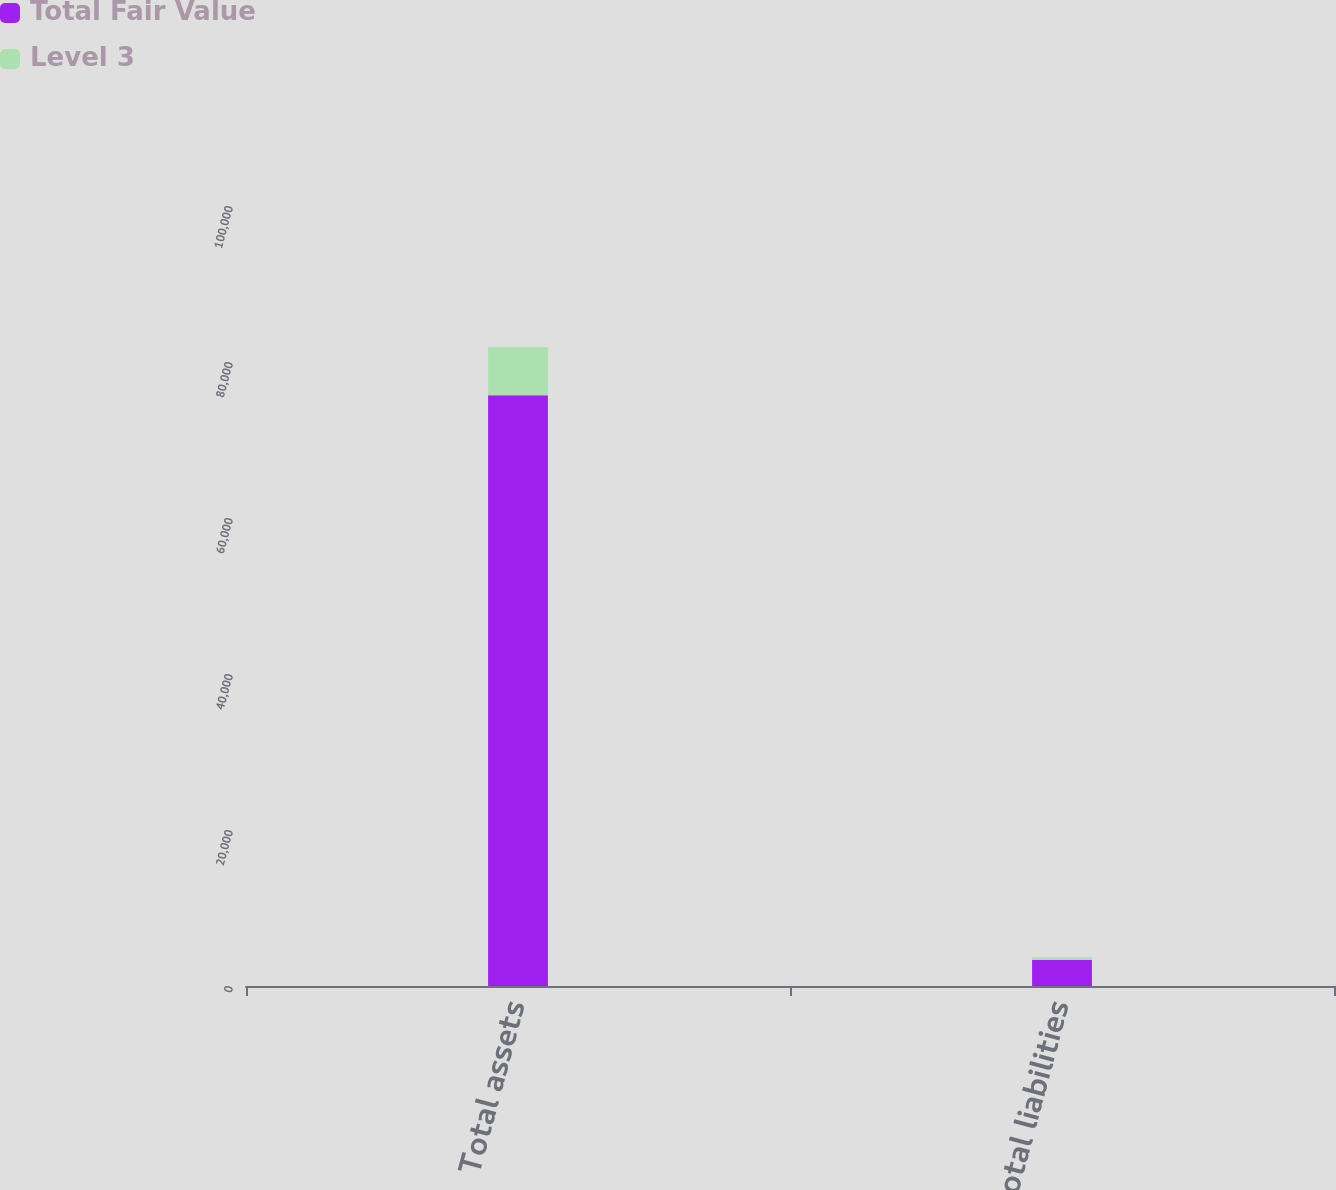Convert chart. <chart><loc_0><loc_0><loc_500><loc_500><stacked_bar_chart><ecel><fcel>Total assets<fcel>Total liabilities<nl><fcel>Total Fair Value<fcel>75744<fcel>3355<nl><fcel>Level 3<fcel>6157<fcel>333<nl></chart> 